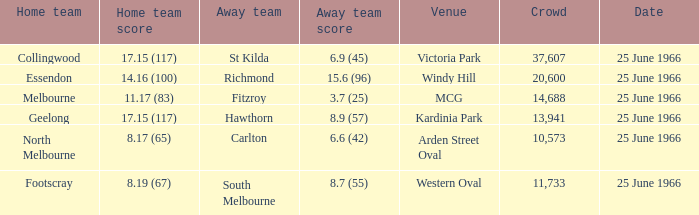Where did the away team score 8.7 (55)? Western Oval. 